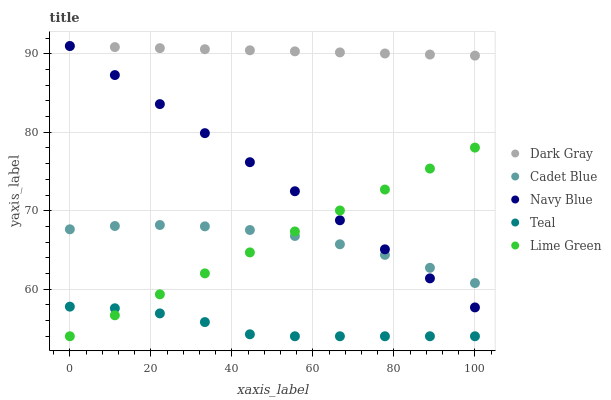Does Teal have the minimum area under the curve?
Answer yes or no. Yes. Does Dark Gray have the maximum area under the curve?
Answer yes or no. Yes. Does Navy Blue have the minimum area under the curve?
Answer yes or no. No. Does Navy Blue have the maximum area under the curve?
Answer yes or no. No. Is Lime Green the smoothest?
Answer yes or no. Yes. Is Teal the roughest?
Answer yes or no. Yes. Is Navy Blue the smoothest?
Answer yes or no. No. Is Navy Blue the roughest?
Answer yes or no. No. Does Lime Green have the lowest value?
Answer yes or no. Yes. Does Navy Blue have the lowest value?
Answer yes or no. No. Does Navy Blue have the highest value?
Answer yes or no. Yes. Does Cadet Blue have the highest value?
Answer yes or no. No. Is Teal less than Navy Blue?
Answer yes or no. Yes. Is Dark Gray greater than Cadet Blue?
Answer yes or no. Yes. Does Cadet Blue intersect Lime Green?
Answer yes or no. Yes. Is Cadet Blue less than Lime Green?
Answer yes or no. No. Is Cadet Blue greater than Lime Green?
Answer yes or no. No. Does Teal intersect Navy Blue?
Answer yes or no. No. 